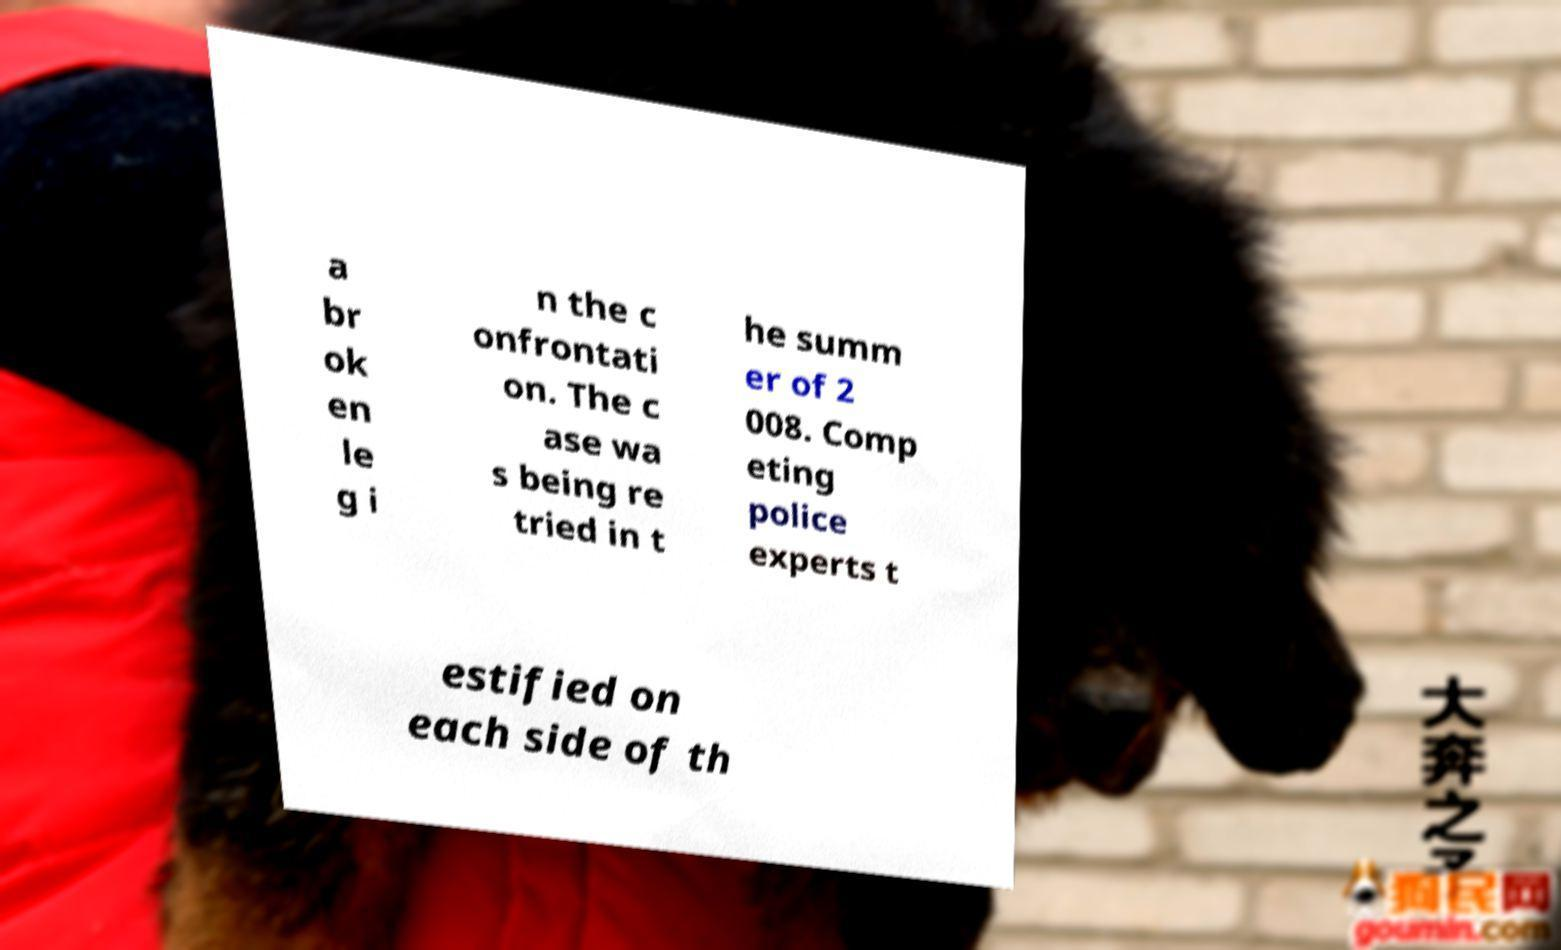Please read and relay the text visible in this image. What does it say? a br ok en le g i n the c onfrontati on. The c ase wa s being re tried in t he summ er of 2 008. Comp eting police experts t estified on each side of th 